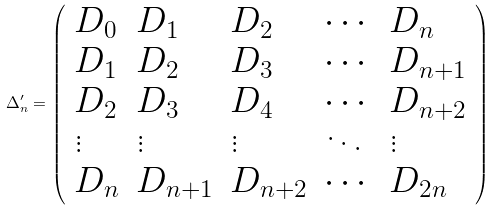Convert formula to latex. <formula><loc_0><loc_0><loc_500><loc_500>\Delta ^ { \prime } _ { n } = \left ( \begin{array} { l l l l l } D _ { 0 } & D _ { 1 } & D _ { 2 } & \cdots & D _ { n } \\ D _ { 1 } & D _ { 2 } & D _ { 3 } & \cdots & D _ { n + 1 } \\ D _ { 2 } & D _ { 3 } & D _ { 4 } & \cdots & D _ { n + 2 } \\ \vdots & \vdots & \vdots & \ddots & \vdots \\ D _ { n } & D _ { n + 1 } & D _ { n + 2 } & \cdots & D _ { 2 n } \end{array} \right )</formula> 